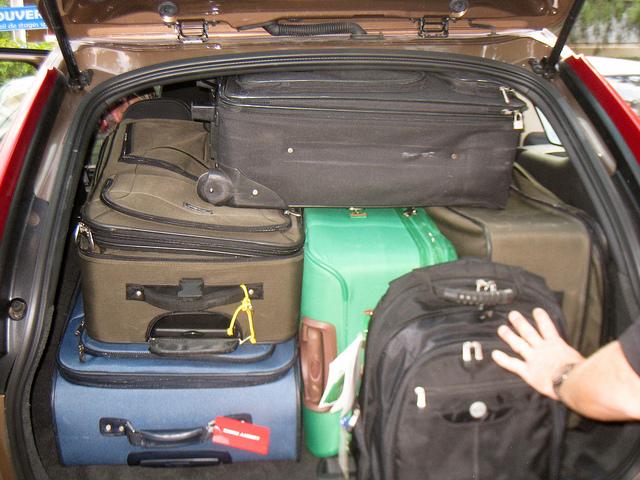What is in the green bottle at the back of the trunk?
Be succinct. Water. How many people are in the picture?
Short answer required. 1. What does the sign say in the background?
Give a very brief answer. Over. Do any of these travel bags have wheels?
Give a very brief answer. Yes. 